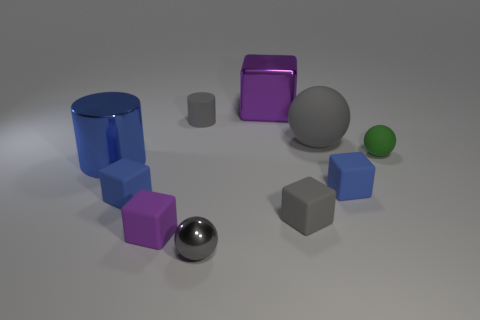Subtract 1 balls. How many balls are left? 2 Subtract all gray cubes. How many cubes are left? 4 Subtract all tiny gray rubber blocks. How many blocks are left? 4 Subtract all brown blocks. Subtract all purple cylinders. How many blocks are left? 5 Subtract all spheres. How many objects are left? 7 Subtract 0 purple cylinders. How many objects are left? 10 Subtract all rubber cubes. Subtract all big purple blocks. How many objects are left? 5 Add 8 green objects. How many green objects are left? 9 Add 2 rubber cubes. How many rubber cubes exist? 6 